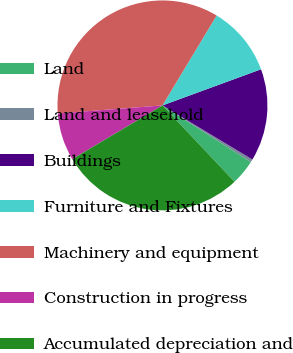<chart> <loc_0><loc_0><loc_500><loc_500><pie_chart><fcel>Land<fcel>Land and leasehold<fcel>Buildings<fcel>Furniture and Fixtures<fcel>Machinery and equipment<fcel>Construction in progress<fcel>Accumulated depreciation and<nl><fcel>3.89%<fcel>0.45%<fcel>14.21%<fcel>10.77%<fcel>34.86%<fcel>7.33%<fcel>28.49%<nl></chart> 